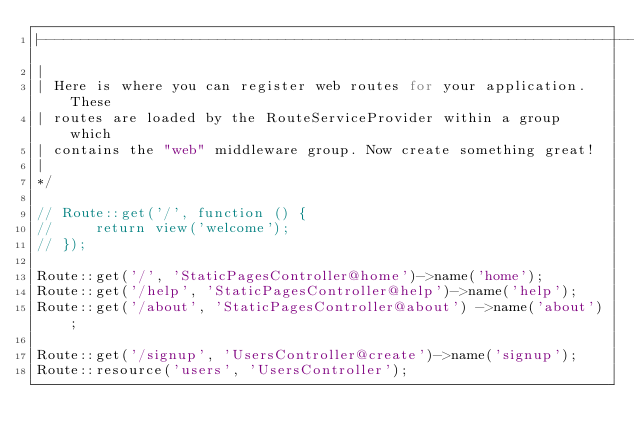<code> <loc_0><loc_0><loc_500><loc_500><_PHP_>|--------------------------------------------------------------------------
|
| Here is where you can register web routes for your application. These
| routes are loaded by the RouteServiceProvider within a group which
| contains the "web" middleware group. Now create something great!
|
*/

// Route::get('/', function () {
//     return view('welcome');
// });

Route::get('/', 'StaticPagesController@home')->name('home');
Route::get('/help', 'StaticPagesController@help')->name('help');
Route::get('/about', 'StaticPagesController@about') ->name('about');

Route::get('/signup', 'UsersController@create')->name('signup');
Route::resource('users', 'UsersController');
</code> 